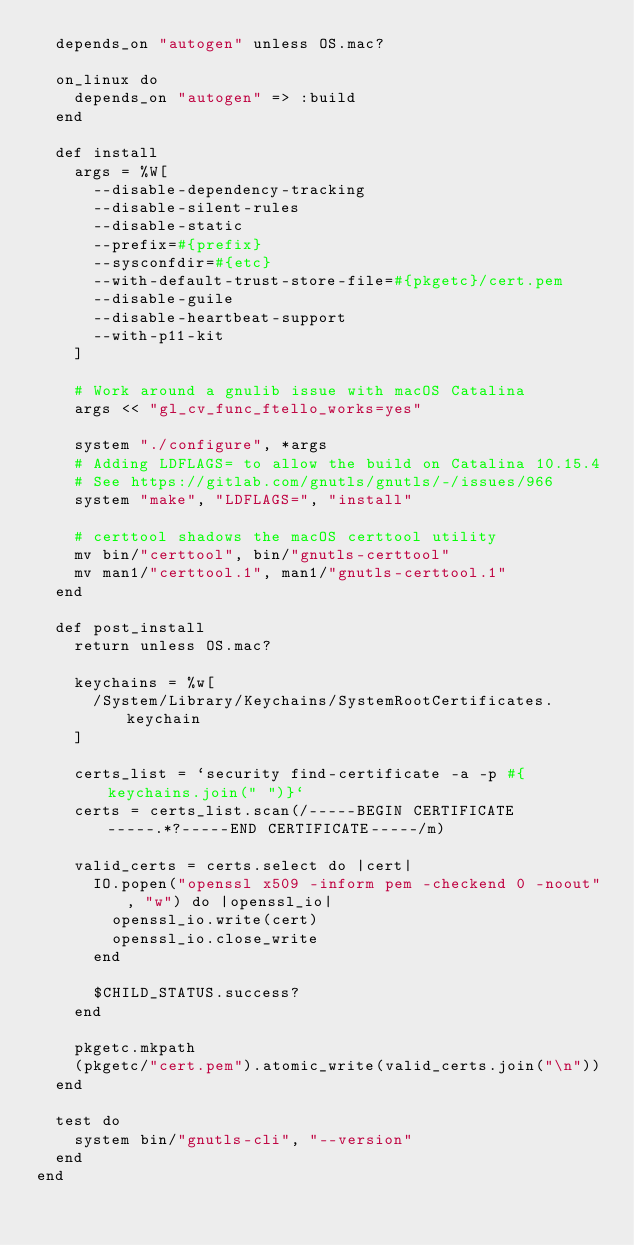<code> <loc_0><loc_0><loc_500><loc_500><_Ruby_>  depends_on "autogen" unless OS.mac?

  on_linux do
    depends_on "autogen" => :build
  end

  def install
    args = %W[
      --disable-dependency-tracking
      --disable-silent-rules
      --disable-static
      --prefix=#{prefix}
      --sysconfdir=#{etc}
      --with-default-trust-store-file=#{pkgetc}/cert.pem
      --disable-guile
      --disable-heartbeat-support
      --with-p11-kit
    ]

    # Work around a gnulib issue with macOS Catalina
    args << "gl_cv_func_ftello_works=yes"

    system "./configure", *args
    # Adding LDFLAGS= to allow the build on Catalina 10.15.4
    # See https://gitlab.com/gnutls/gnutls/-/issues/966
    system "make", "LDFLAGS=", "install"

    # certtool shadows the macOS certtool utility
    mv bin/"certtool", bin/"gnutls-certtool"
    mv man1/"certtool.1", man1/"gnutls-certtool.1"
  end

  def post_install
    return unless OS.mac?

    keychains = %w[
      /System/Library/Keychains/SystemRootCertificates.keychain
    ]

    certs_list = `security find-certificate -a -p #{keychains.join(" ")}`
    certs = certs_list.scan(/-----BEGIN CERTIFICATE-----.*?-----END CERTIFICATE-----/m)

    valid_certs = certs.select do |cert|
      IO.popen("openssl x509 -inform pem -checkend 0 -noout", "w") do |openssl_io|
        openssl_io.write(cert)
        openssl_io.close_write
      end

      $CHILD_STATUS.success?
    end

    pkgetc.mkpath
    (pkgetc/"cert.pem").atomic_write(valid_certs.join("\n"))
  end

  test do
    system bin/"gnutls-cli", "--version"
  end
end
</code> 